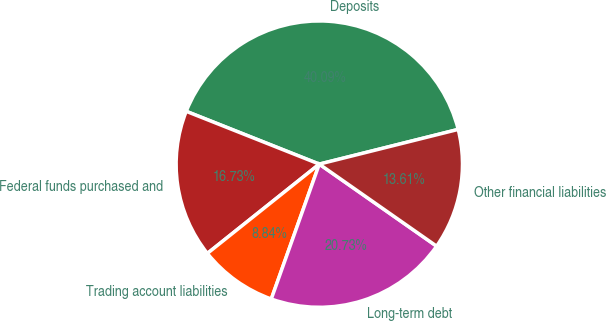Convert chart to OTSL. <chart><loc_0><loc_0><loc_500><loc_500><pie_chart><fcel>Deposits<fcel>Federal funds purchased and<fcel>Trading account liabilities<fcel>Long-term debt<fcel>Other financial liabilities<nl><fcel>40.09%<fcel>16.73%<fcel>8.84%<fcel>20.73%<fcel>13.61%<nl></chart> 